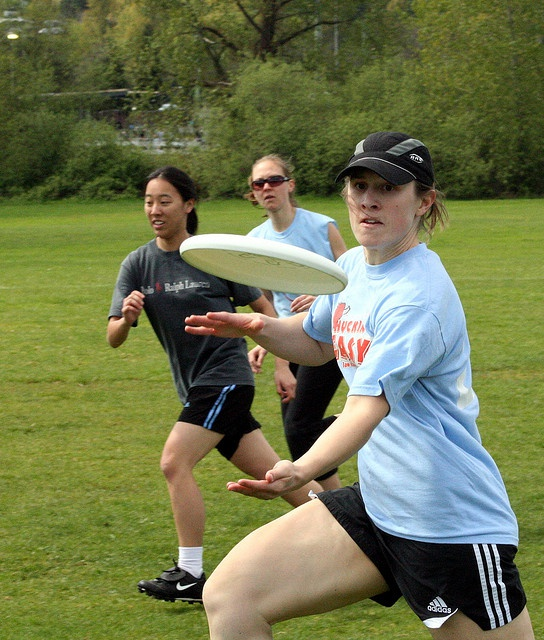Describe the objects in this image and their specific colors. I can see people in olive, black, lightblue, and white tones, people in olive, black, and gray tones, people in olive, black, tan, gray, and lightblue tones, and frisbee in olive, ivory, darkgray, and black tones in this image. 